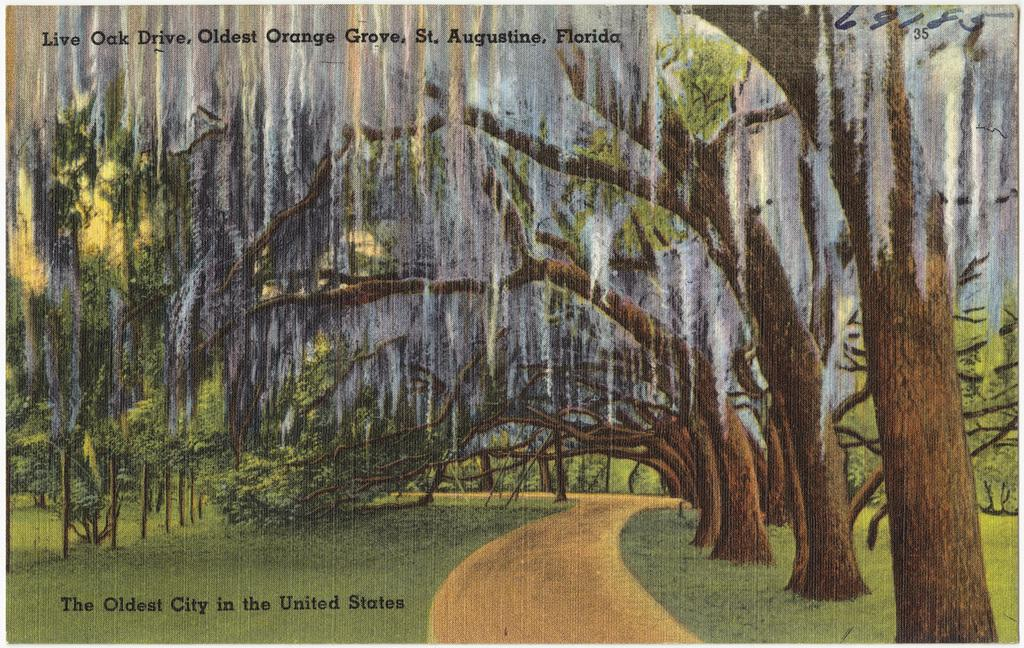What is the main subject of the image? There is a painting in the image. What is depicted in the painting? The painting contains trees. What is written at the top of the image? There is text at the top of the image. What is present at the bottom of the image? There are numbers at the bottom of the image. What type of test can be seen being administered in the image? There is no test present in the image; it features a painting with trees and text at the top and numbers at the bottom. Can you tell me how many quills are visible in the image? There is no quill present in the image. 